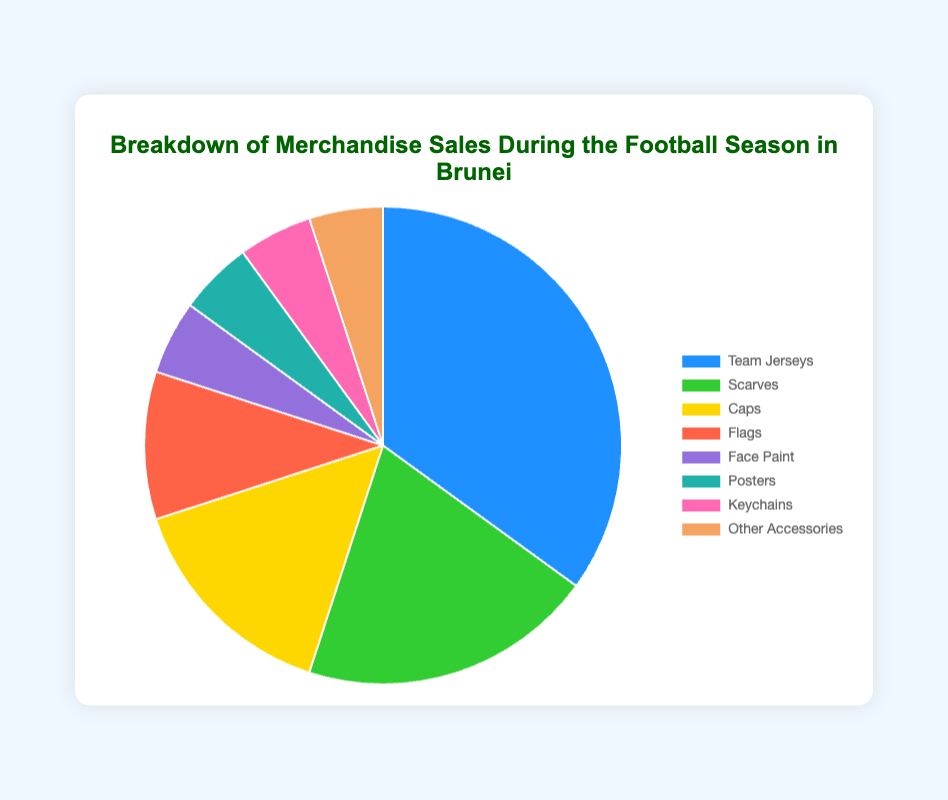What percentage of merchandise sales do items other than team jerseys contribute? To find this, subtract the percentage of team jerseys from the total percentage. Total = 100%, Percentage of team jerseys = 35%, so 100% - 35% = 65%
Answer: 65% Which item has the highest sales percentage? The pie chart shows that team jerseys have the largest sales percentage, which is 35%
Answer: Team jerseys What is the combined sales percentage for face paint, posters, keychains, and other accessories? Add the percentages of all these items: Face paint (5%) + Posters (5%) + Keychains (5%) + Other accessories (5%) = 20%
Answer: 20% Are the sales of caps greater than or less than the sales of scarves? Compare the percentages of caps (15%) and scarves (20%); caps have a smaller percentage than scarves.
Answer: Less than How many items have a sales percentage less than or equal to 5%? The items with percentages equal to 5% are Face Paint, Posters, Keychains, and Other Accessories, totaling 4 items.
Answer: 4 items If we combine the sales percentages of caps and flags, do they exceed the sales percentage of team jerseys? Add the sales percentages of caps (15%) and flags (10%) which is 25%. Team jerseys have 35%, so 25% does not exceed 35%.
Answer: No What color is used to represent the "Flags" category in the pie chart? The pie chart uses the color red to represent flags
Answer: Red Which two items have the same sales percentage and what is that percentage? The visual information indicates that Face Paint, Posters, Keychains, and Other Accessories all have the same sales percentage of 5% each.
Answer: 5% What is the difference in sales percentage between team jerseys and caps? Subtract the sales percentage of caps (15%) from team jerseys (35%); the difference is 35% - 15% = 20%.
Answer: 20% If you were to group ‘Face Paint’, ‘Posters’, ‘Keychains’, and ‘Other Accessories’ together, how would this group's total sales percentage compare to that of scarves? Combined percentage for Face Paint, Posters, Keychains, and Other Accessories is 20%. Scarves have a sales percentage of 20%, so they are equal.
Answer: Equal 